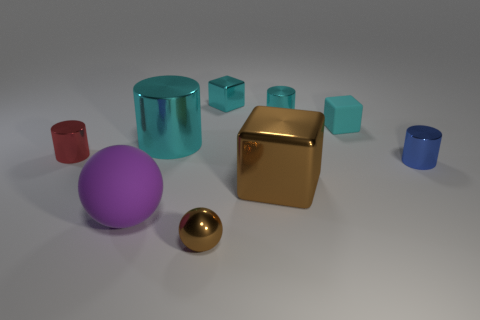How many small cyan matte things are to the right of the tiny cyan metallic object that is to the right of the brown thing behind the purple sphere? 1 